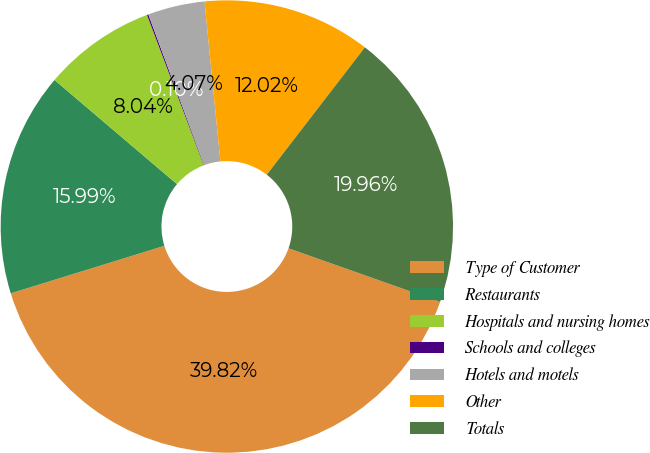Convert chart. <chart><loc_0><loc_0><loc_500><loc_500><pie_chart><fcel>Type of Customer<fcel>Restaurants<fcel>Hospitals and nursing homes<fcel>Schools and colleges<fcel>Hotels and motels<fcel>Other<fcel>Totals<nl><fcel>39.82%<fcel>15.99%<fcel>8.04%<fcel>0.1%<fcel>4.07%<fcel>12.02%<fcel>19.96%<nl></chart> 